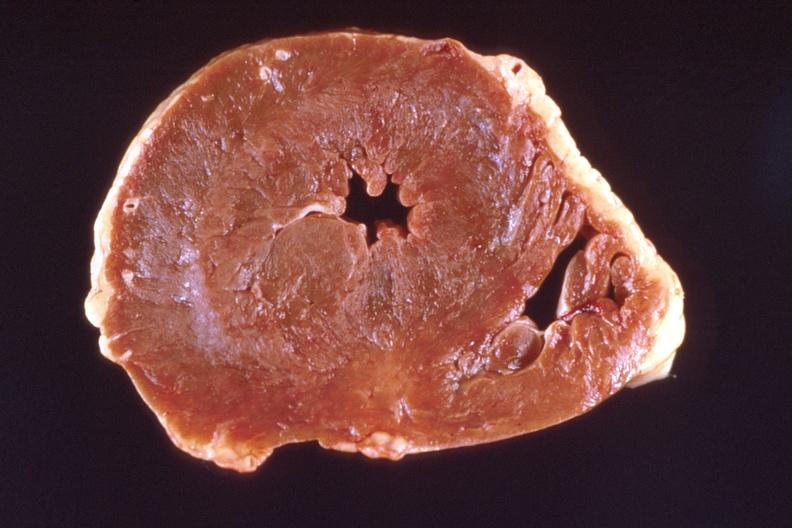what does this image show?
Answer the question using a single word or phrase. Heart 